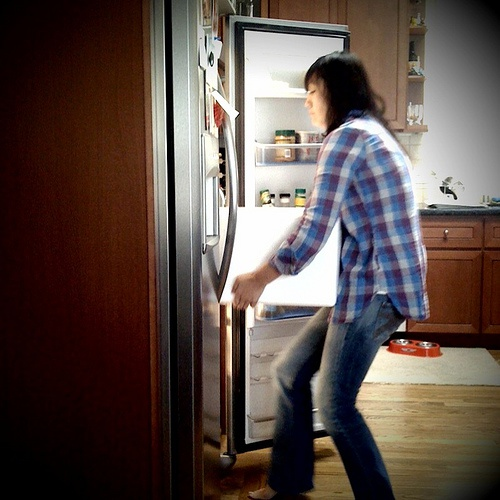Describe the objects in this image and their specific colors. I can see refrigerator in black, lightgray, maroon, and darkgray tones, people in black, gray, and darkgray tones, and sink in black, gray, darkgray, and lightgray tones in this image. 